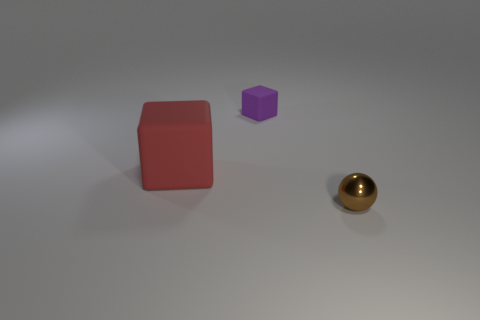Subtract all blue blocks. Subtract all green cylinders. How many blocks are left? 2 Add 1 small brown matte cylinders. How many objects exist? 4 Subtract all cubes. How many objects are left? 1 Subtract all big red matte blocks. Subtract all metallic spheres. How many objects are left? 1 Add 2 tiny brown metal objects. How many tiny brown metal objects are left? 3 Add 2 tiny balls. How many tiny balls exist? 3 Subtract 0 blue cubes. How many objects are left? 3 